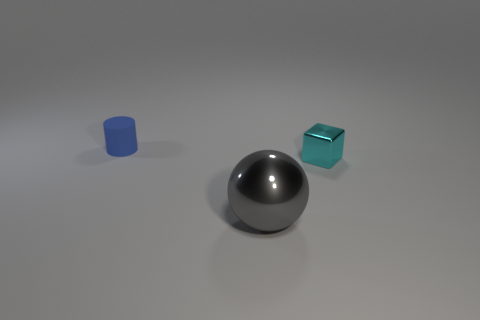Add 1 cyan things. How many objects exist? 4 Subtract all balls. How many objects are left? 2 Add 2 small cyan metal objects. How many small cyan metal objects are left? 3 Add 2 blue things. How many blue things exist? 3 Subtract 0 purple balls. How many objects are left? 3 Subtract all gray metallic things. Subtract all small blue things. How many objects are left? 1 